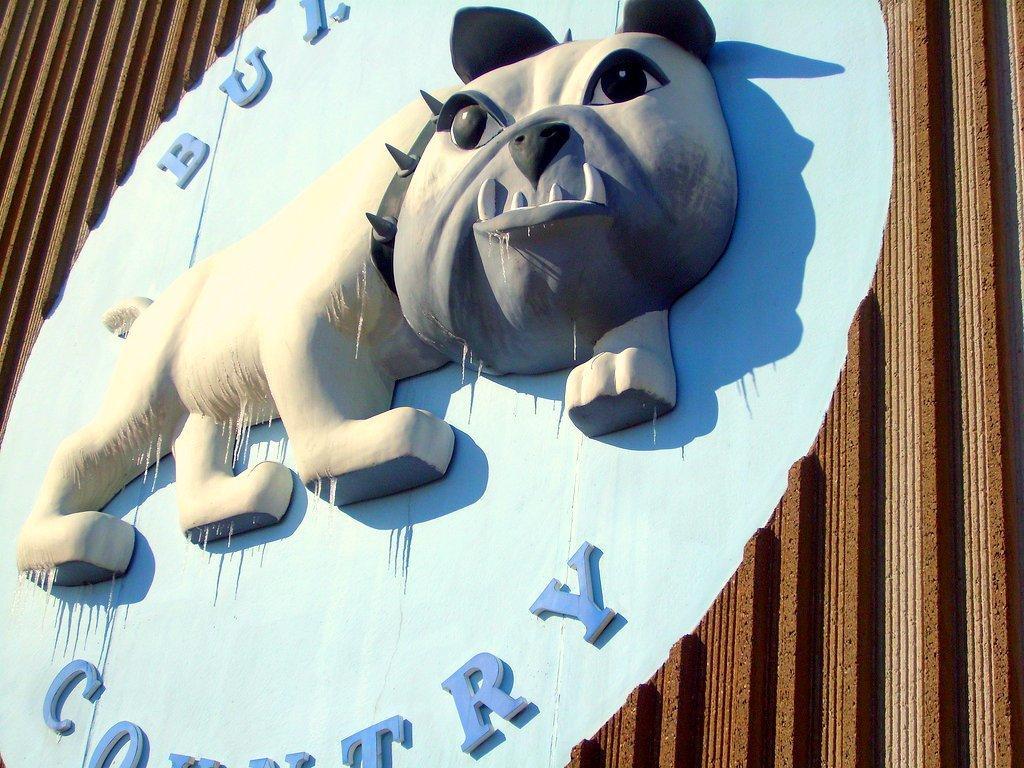Could you give a brief overview of what you see in this image? In this picture we can see a board on wooden object. 